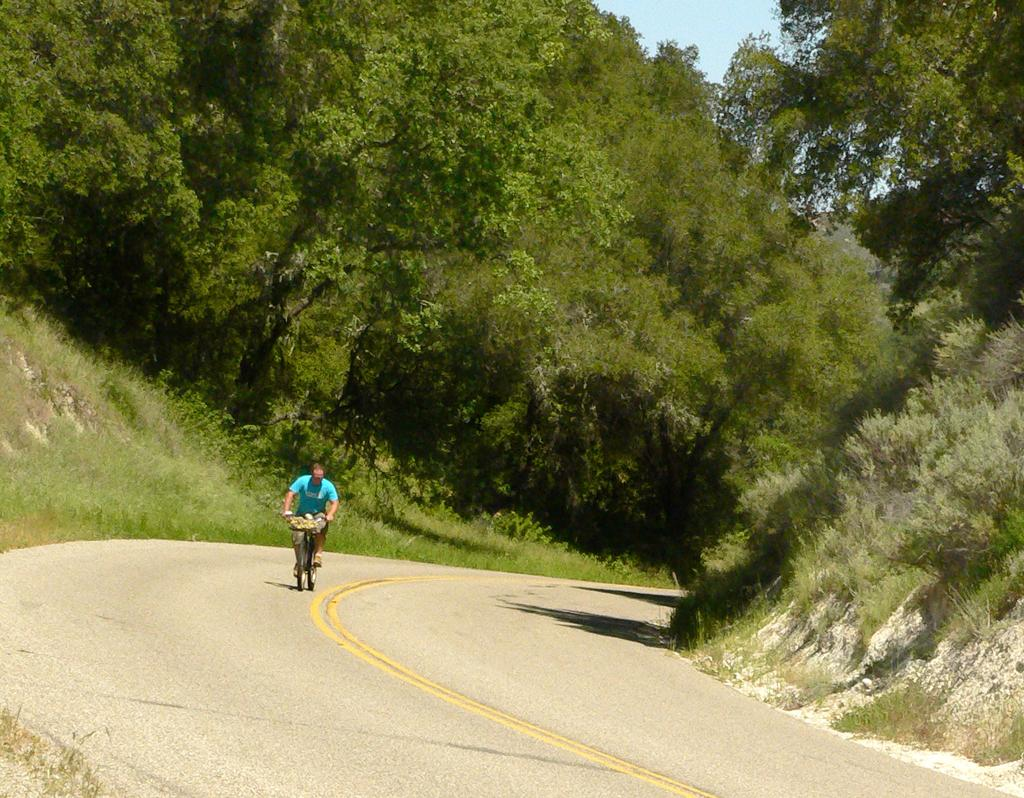What is the person in the image doing? The person is riding a bicycle. Where is the bicycle located? The bicycle is on the road. What can be seen in the background of the image? There are trees in the background of the image. What type of wood can be seen in the image? There is no wood present in the image; it features a person riding a bicycle on the road with trees in the background. Is there any blood visible in the image? No, there is no blood visible in the image. 